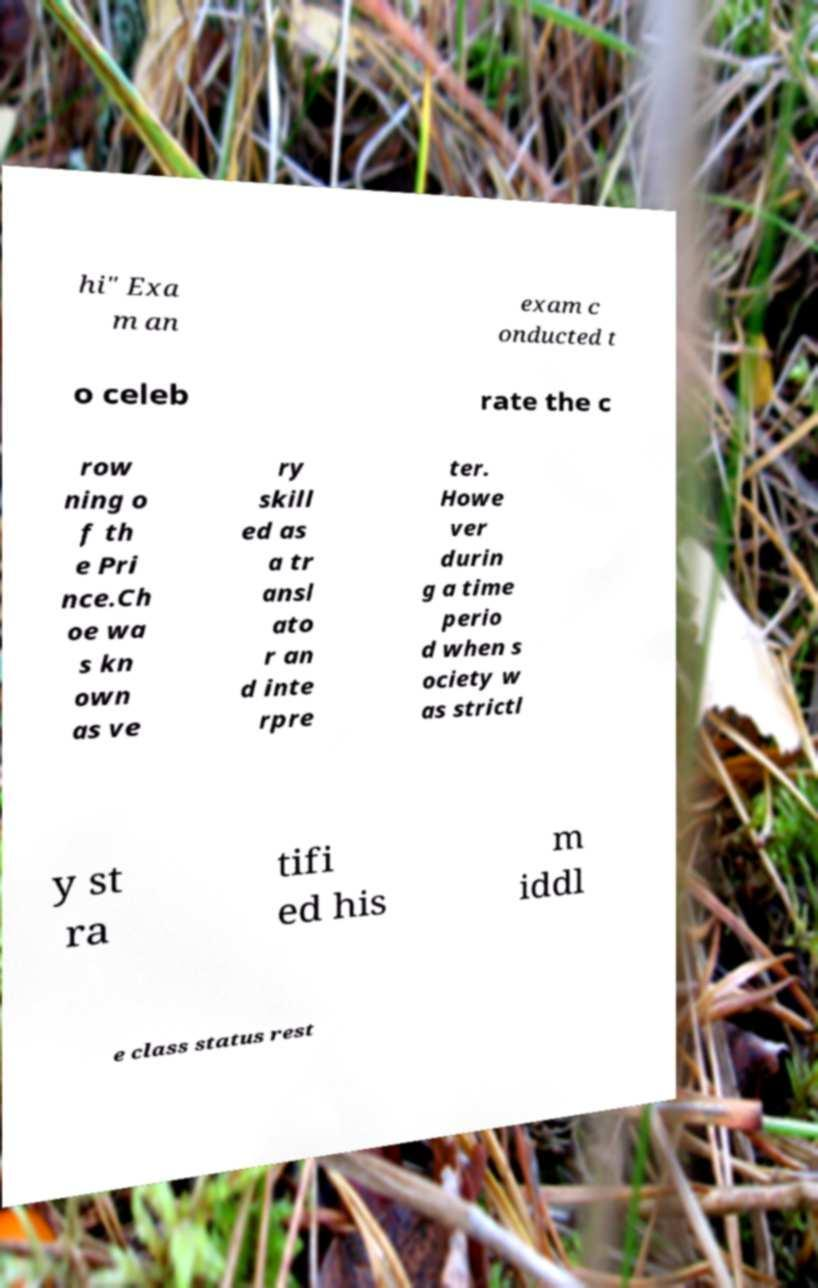Could you extract and type out the text from this image? hi" Exa m an exam c onducted t o celeb rate the c row ning o f th e Pri nce.Ch oe wa s kn own as ve ry skill ed as a tr ansl ato r an d inte rpre ter. Howe ver durin g a time perio d when s ociety w as strictl y st ra tifi ed his m iddl e class status rest 